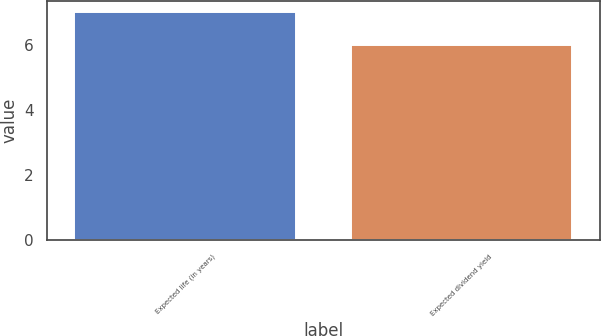Convert chart to OTSL. <chart><loc_0><loc_0><loc_500><loc_500><bar_chart><fcel>Expected life (in years)<fcel>Expected dividend yield<nl><fcel>7<fcel>6<nl></chart> 